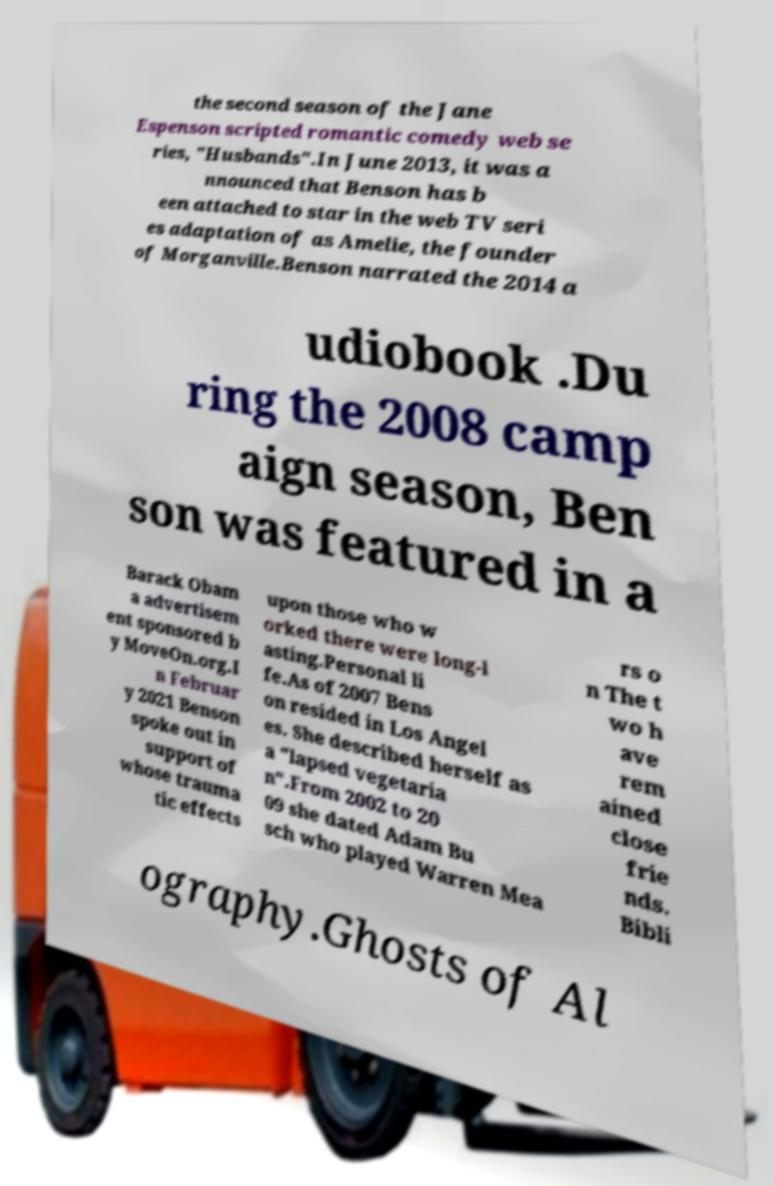Can you accurately transcribe the text from the provided image for me? the second season of the Jane Espenson scripted romantic comedy web se ries, "Husbands".In June 2013, it was a nnounced that Benson has b een attached to star in the web TV seri es adaptation of as Amelie, the founder of Morganville.Benson narrated the 2014 a udiobook .Du ring the 2008 camp aign season, Ben son was featured in a Barack Obam a advertisem ent sponsored b y MoveOn.org.I n Februar y 2021 Benson spoke out in support of whose trauma tic effects upon those who w orked there were long-l asting.Personal li fe.As of 2007 Bens on resided in Los Angel es. She described herself as a "lapsed vegetaria n".From 2002 to 20 09 she dated Adam Bu sch who played Warren Mea rs o n The t wo h ave rem ained close frie nds. Bibli ography.Ghosts of Al 